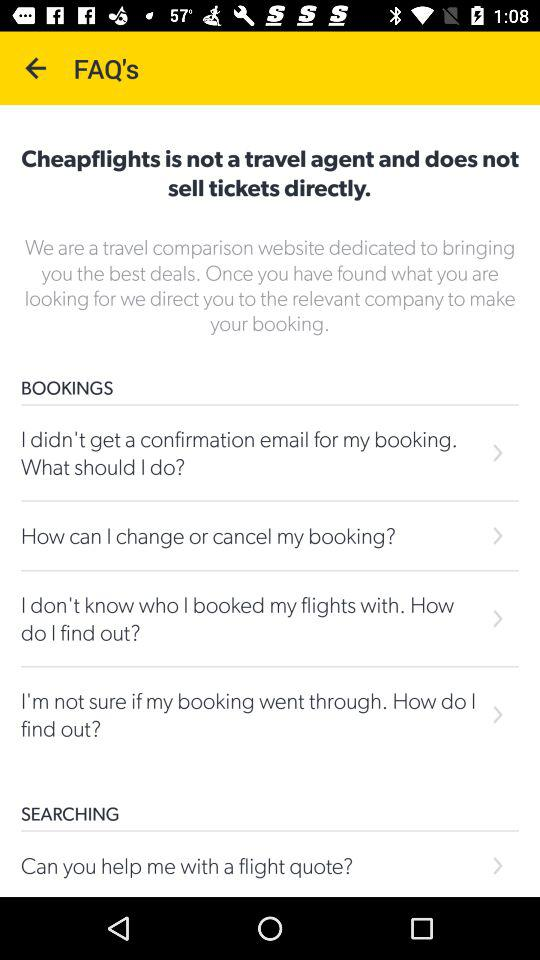How many FAQs are there about Searching?
Answer the question using a single word or phrase. 1 